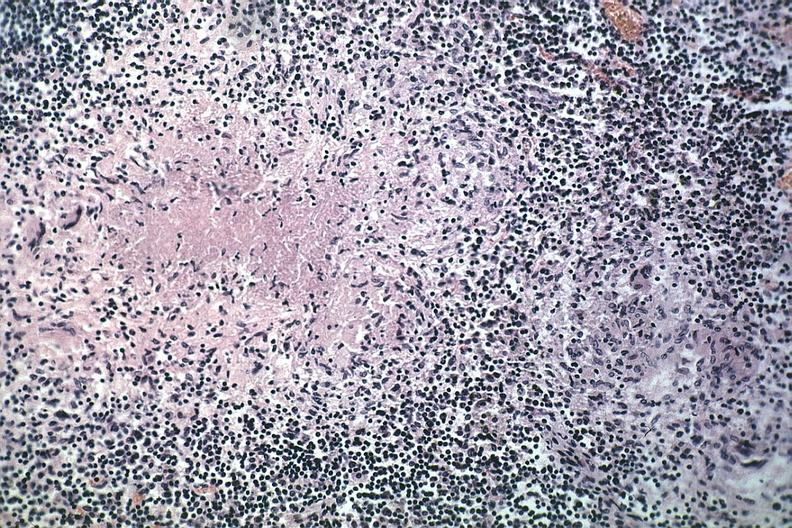how does this image show typical area of caseous necrosis?
Answer the question using a single word or phrase. With nearby early granuloma quite good source unknown 